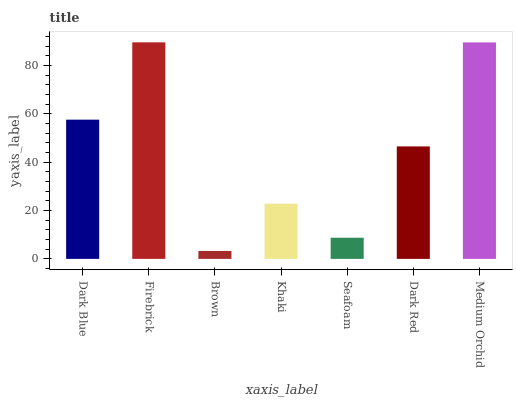Is Firebrick the minimum?
Answer yes or no. No. Is Brown the maximum?
Answer yes or no. No. Is Firebrick greater than Brown?
Answer yes or no. Yes. Is Brown less than Firebrick?
Answer yes or no. Yes. Is Brown greater than Firebrick?
Answer yes or no. No. Is Firebrick less than Brown?
Answer yes or no. No. Is Dark Red the high median?
Answer yes or no. Yes. Is Dark Red the low median?
Answer yes or no. Yes. Is Brown the high median?
Answer yes or no. No. Is Medium Orchid the low median?
Answer yes or no. No. 